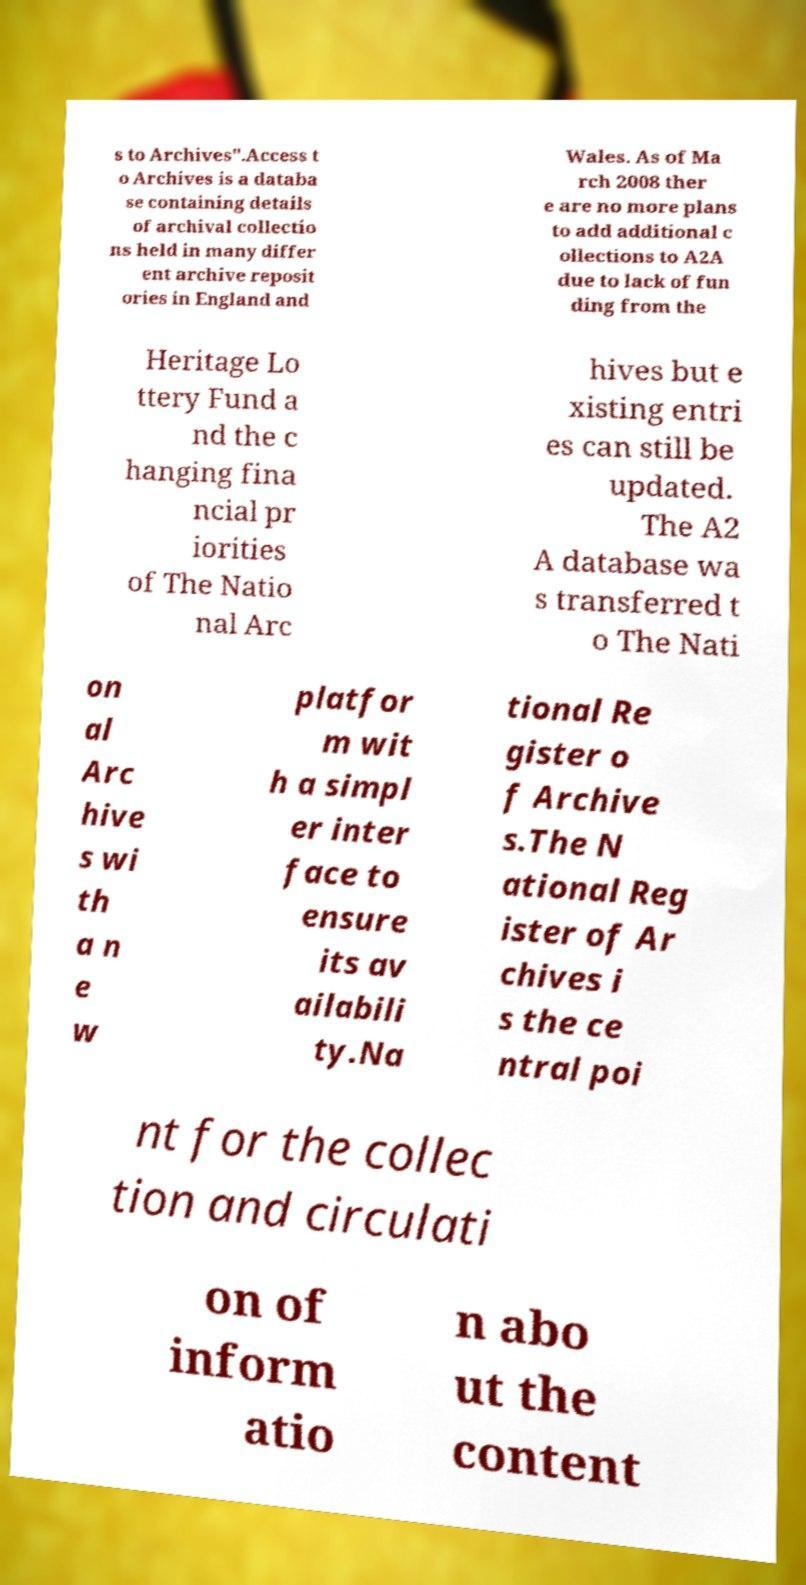Can you accurately transcribe the text from the provided image for me? s to Archives".Access t o Archives is a databa se containing details of archival collectio ns held in many differ ent archive reposit ories in England and Wales. As of Ma rch 2008 ther e are no more plans to add additional c ollections to A2A due to lack of fun ding from the Heritage Lo ttery Fund a nd the c hanging fina ncial pr iorities of The Natio nal Arc hives but e xisting entri es can still be updated. The A2 A database wa s transferred t o The Nati on al Arc hive s wi th a n e w platfor m wit h a simpl er inter face to ensure its av ailabili ty.Na tional Re gister o f Archive s.The N ational Reg ister of Ar chives i s the ce ntral poi nt for the collec tion and circulati on of inform atio n abo ut the content 